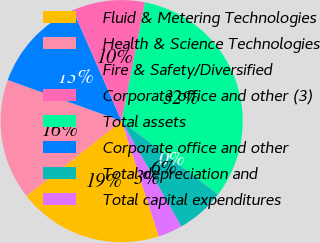Convert chart to OTSL. <chart><loc_0><loc_0><loc_500><loc_500><pie_chart><fcel>Fluid & Metering Technologies<fcel>Health & Science Technologies<fcel>Fire & Safety/Diversified<fcel>Corporate office and other (3)<fcel>Total assets<fcel>Corporate office and other<fcel>Total depreciation and<fcel>Total capital expenditures<nl><fcel>19.35%<fcel>16.13%<fcel>12.9%<fcel>9.68%<fcel>32.25%<fcel>0.0%<fcel>6.45%<fcel>3.23%<nl></chart> 